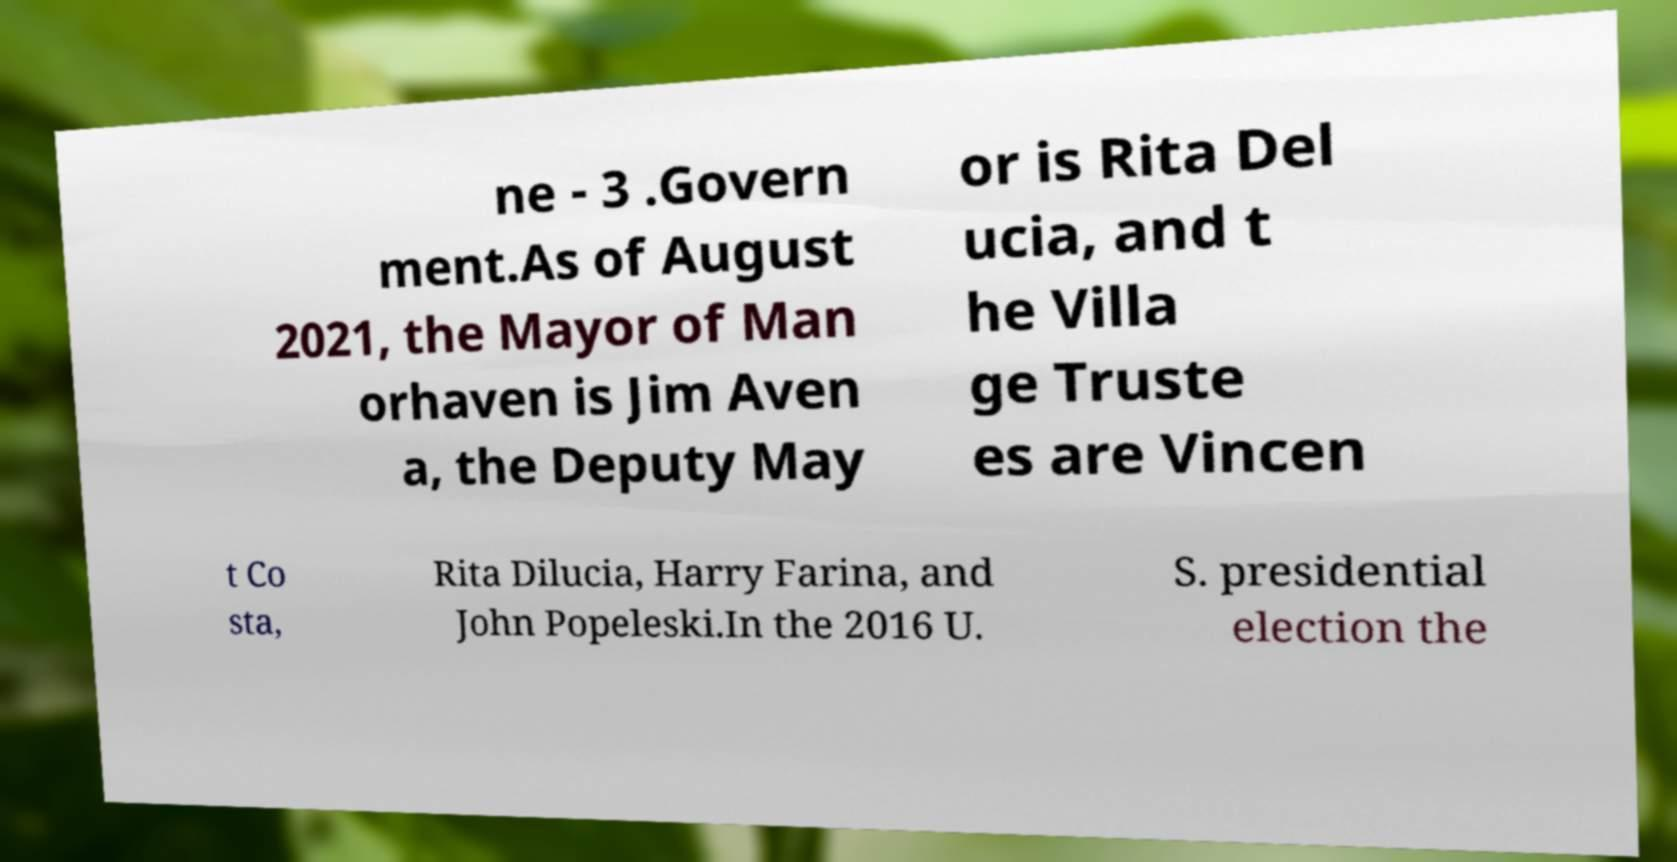For documentation purposes, I need the text within this image transcribed. Could you provide that? ne - 3 .Govern ment.As of August 2021, the Mayor of Man orhaven is Jim Aven a, the Deputy May or is Rita Del ucia, and t he Villa ge Truste es are Vincen t Co sta, Rita Dilucia, Harry Farina, and John Popeleski.In the 2016 U. S. presidential election the 